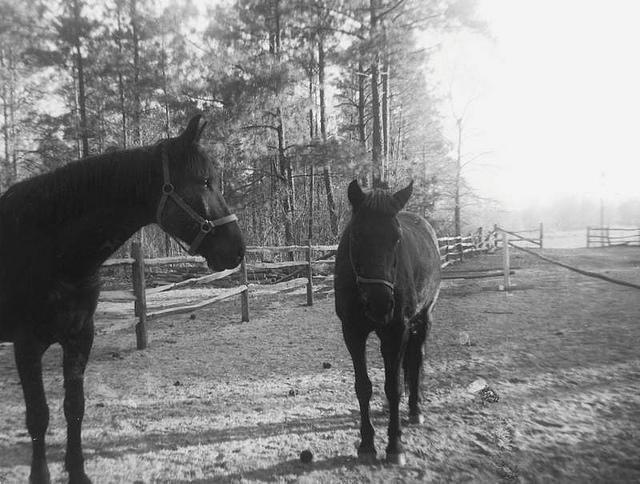How many horses are there?
Give a very brief answer. 2. 